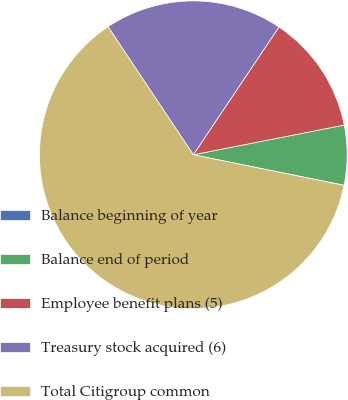<chart> <loc_0><loc_0><loc_500><loc_500><pie_chart><fcel>Balance beginning of year<fcel>Balance end of period<fcel>Employee benefit plans (5)<fcel>Treasury stock acquired (6)<fcel>Total Citigroup common<nl><fcel>0.02%<fcel>6.26%<fcel>12.51%<fcel>18.75%<fcel>62.46%<nl></chart> 